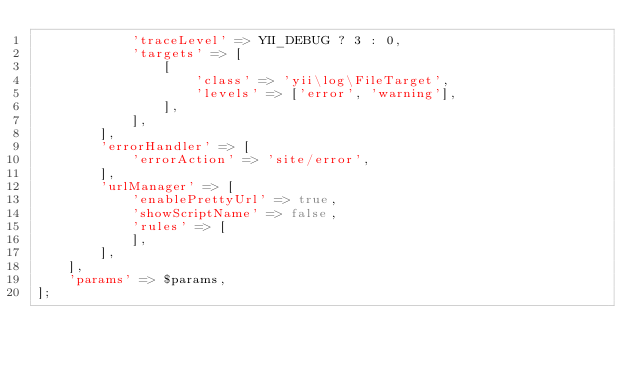<code> <loc_0><loc_0><loc_500><loc_500><_PHP_>            'traceLevel' => YII_DEBUG ? 3 : 0,
            'targets' => [
                [
                    'class' => 'yii\log\FileTarget',
                    'levels' => ['error', 'warning'],
                ],
            ],
        ],
        'errorHandler' => [
            'errorAction' => 'site/error',
        ],
        'urlManager' => [
            'enablePrettyUrl' => true,
            'showScriptName' => false,
            'rules' => [
            ],
        ],
    ],
    'params' => $params,
];
</code> 